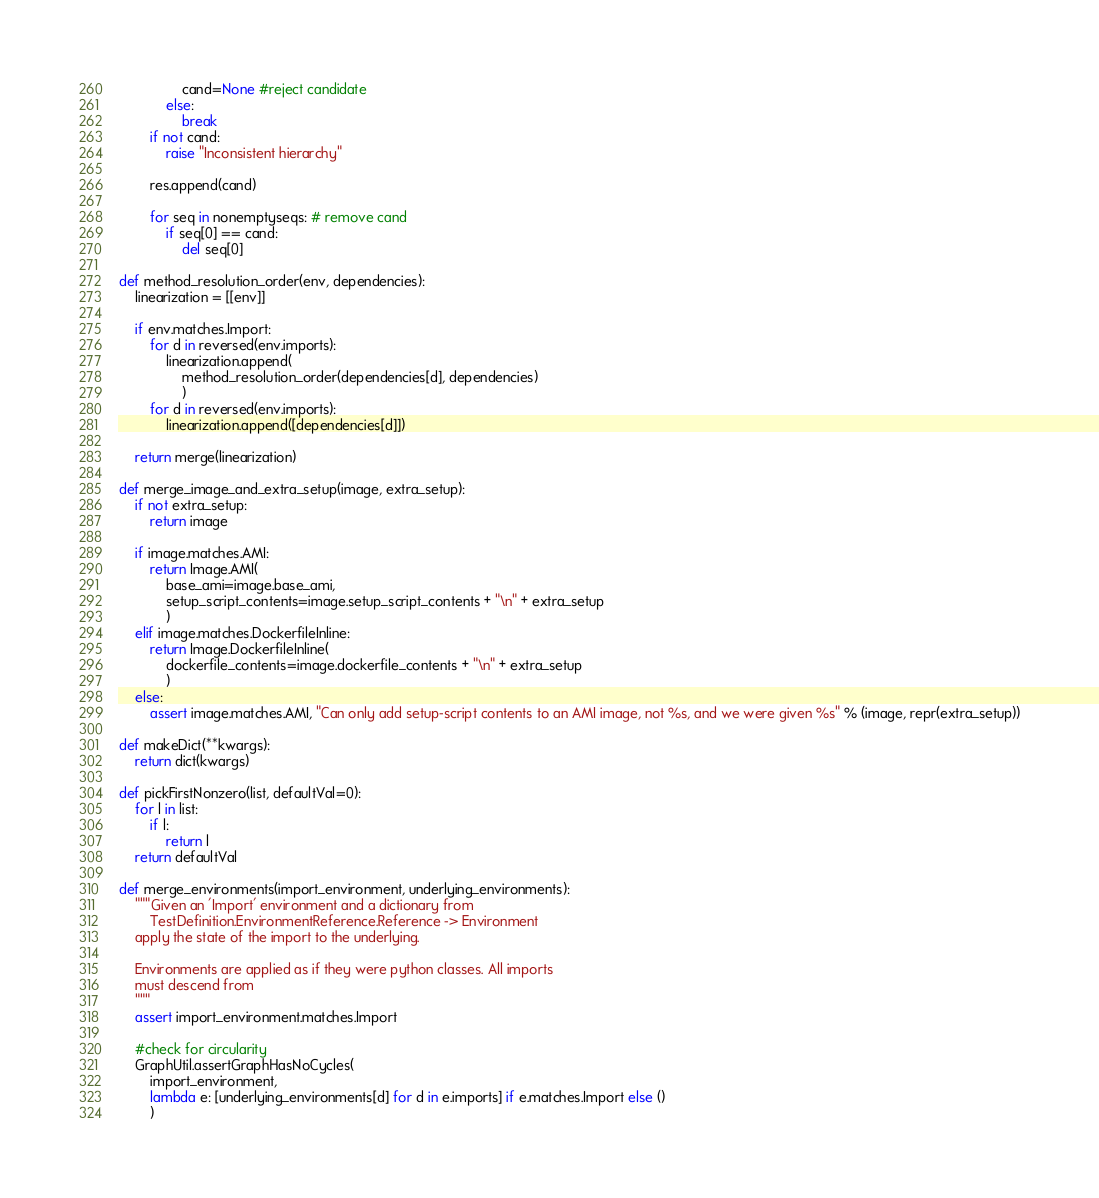<code> <loc_0><loc_0><loc_500><loc_500><_Python_>                cand=None #reject candidate
            else: 
                break
        if not cand: 
            raise "Inconsistent hierarchy"

        res.append(cand)

        for seq in nonemptyseqs: # remove cand
            if seq[0] == cand: 
                del seq[0]

def method_resolution_order(env, dependencies):
    linearization = [[env]]

    if env.matches.Import:
        for d in reversed(env.imports):
            linearization.append(
                method_resolution_order(dependencies[d], dependencies)
                )
        for d in reversed(env.imports):
            linearization.append([dependencies[d]])

    return merge(linearization)

def merge_image_and_extra_setup(image, extra_setup):
    if not extra_setup:
        return image

    if image.matches.AMI:
        return Image.AMI(
            base_ami=image.base_ami, 
            setup_script_contents=image.setup_script_contents + "\n" + extra_setup
            )
    elif image.matches.DockerfileInline:
        return Image.DockerfileInline(
            dockerfile_contents=image.dockerfile_contents + "\n" + extra_setup
            )
    else:
        assert image.matches.AMI, "Can only add setup-script contents to an AMI image, not %s, and we were given %s" % (image, repr(extra_setup))

def makeDict(**kwargs):
    return dict(kwargs)

def pickFirstNonzero(list, defaultVal=0):
    for l in list:
        if l:
            return l
    return defaultVal

def merge_environments(import_environment, underlying_environments):
    """Given an 'Import' environment and a dictionary from 
        TestDefinition.EnvironmentReference.Reference -> Environment
    apply the state of the import to the underlying.

    Environments are applied as if they were python classes. All imports
    must descend from 
    """
    assert import_environment.matches.Import

    #check for circularity
    GraphUtil.assertGraphHasNoCycles(
        import_environment, 
        lambda e: [underlying_environments[d] for d in e.imports] if e.matches.Import else ()
        )
</code> 